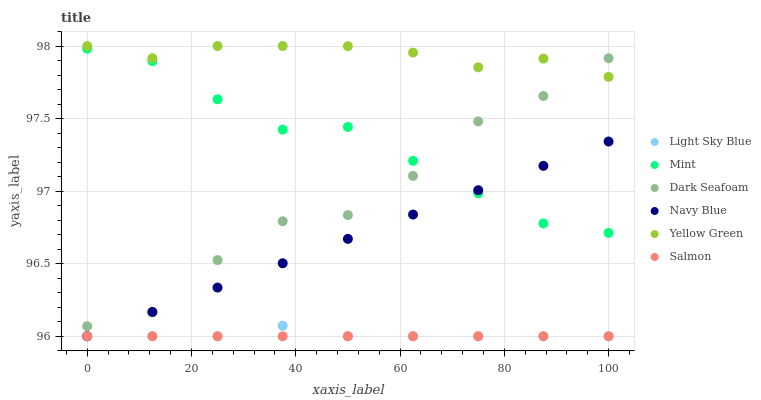Does Salmon have the minimum area under the curve?
Answer yes or no. Yes. Does Yellow Green have the maximum area under the curve?
Answer yes or no. Yes. Does Navy Blue have the minimum area under the curve?
Answer yes or no. No. Does Navy Blue have the maximum area under the curve?
Answer yes or no. No. Is Salmon the smoothest?
Answer yes or no. Yes. Is Dark Seafoam the roughest?
Answer yes or no. Yes. Is Navy Blue the smoothest?
Answer yes or no. No. Is Navy Blue the roughest?
Answer yes or no. No. Does Navy Blue have the lowest value?
Answer yes or no. Yes. Does Dark Seafoam have the lowest value?
Answer yes or no. No. Does Yellow Green have the highest value?
Answer yes or no. Yes. Does Navy Blue have the highest value?
Answer yes or no. No. Is Salmon less than Yellow Green?
Answer yes or no. Yes. Is Mint greater than Light Sky Blue?
Answer yes or no. Yes. Does Navy Blue intersect Dark Seafoam?
Answer yes or no. Yes. Is Navy Blue less than Dark Seafoam?
Answer yes or no. No. Is Navy Blue greater than Dark Seafoam?
Answer yes or no. No. Does Salmon intersect Yellow Green?
Answer yes or no. No. 